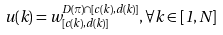Convert formula to latex. <formula><loc_0><loc_0><loc_500><loc_500>u ( k ) = w _ { [ c ( k ) , d ( k ) ] } ^ { D ( \pi ) \cap [ c ( k ) , d ( k ) ] } , \forall k \in [ 1 , N ]</formula> 